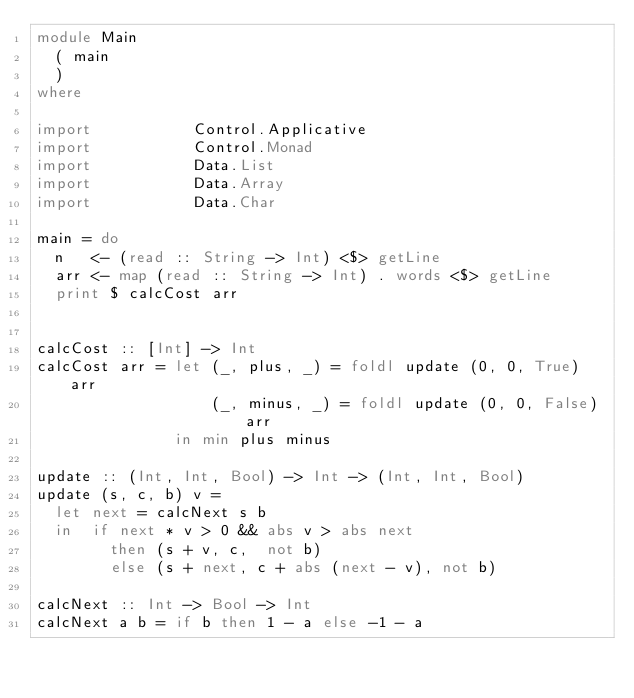Convert code to text. <code><loc_0><loc_0><loc_500><loc_500><_Haskell_>module Main
  ( main
  )
where

import           Control.Applicative
import           Control.Monad
import           Data.List
import           Data.Array
import           Data.Char

main = do
  n   <- (read :: String -> Int) <$> getLine
  arr <- map (read :: String -> Int) . words <$> getLine
  print $ calcCost arr


calcCost :: [Int] -> Int
calcCost arr = let (_, plus, _) = foldl update (0, 0, True) arr
                   (_, minus, _) = foldl update (0, 0, False) arr
               in min plus minus

update :: (Int, Int, Bool) -> Int -> (Int, Int, Bool)
update (s, c, b) v =
  let next = calcNext s b
  in  if next * v > 0 && abs v > abs next
        then (s + v, c,  not b)
        else (s + next, c + abs (next - v), not b)

calcNext :: Int -> Bool -> Int
calcNext a b = if b then 1 - a else -1 - a

</code> 